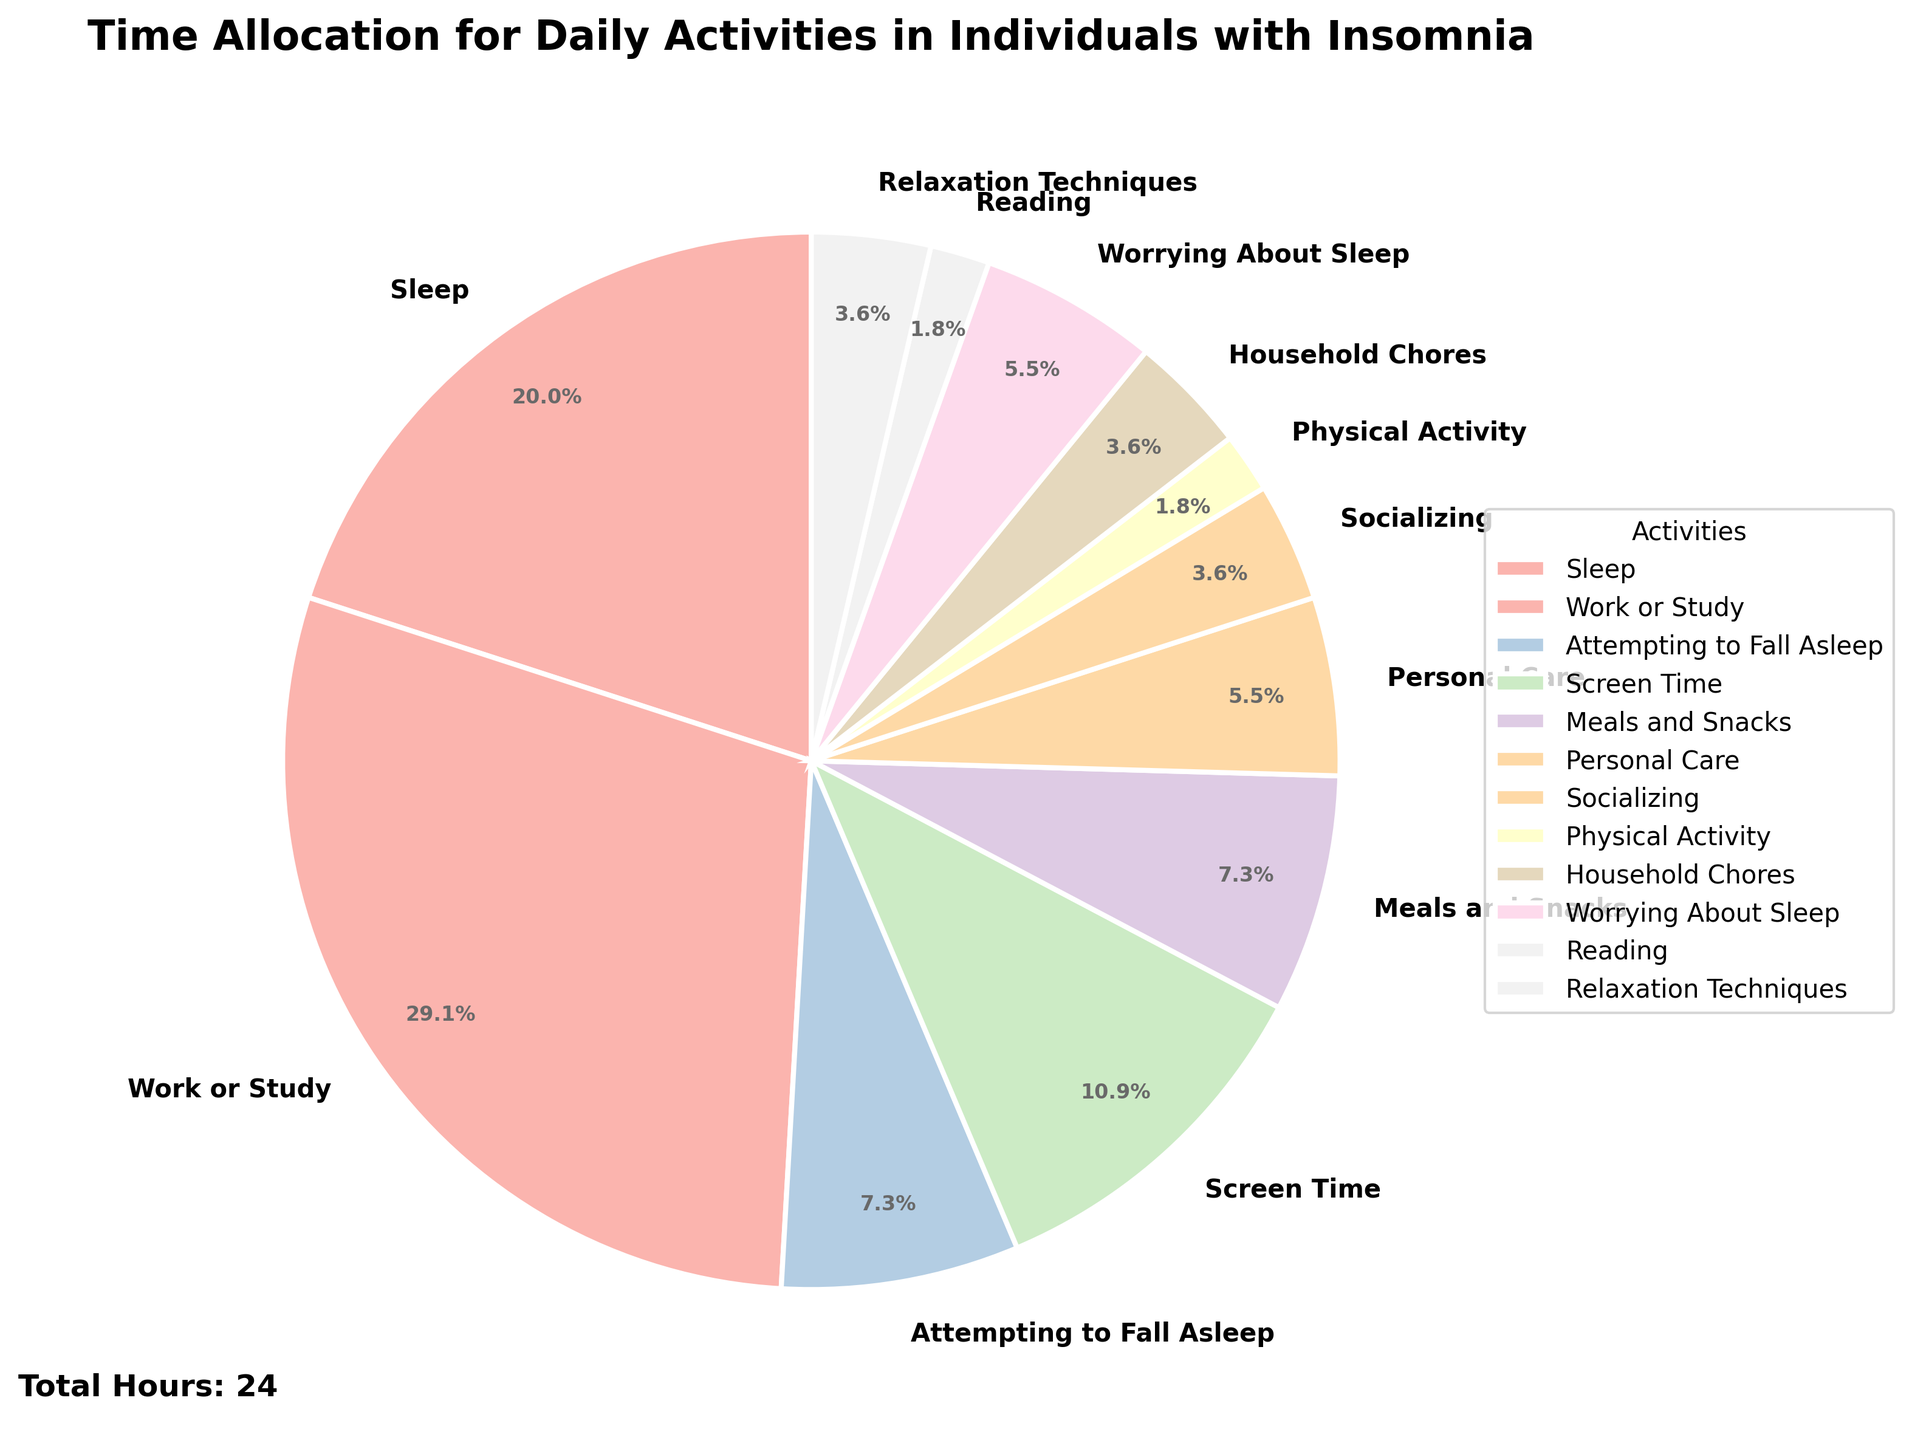What percentage of their day do individuals with insomnia spend on screen time? Total daily hours are 24. Screen time is 3 hours. The percentage is (3/24) * 100.
Answer: 12.5% What activity occupies the largest portion of the day for individuals with insomnia? The activity with the highest hours is Work or Study with 8 hours.
Answer: Work or Study What is the combined percentage of time spent on worrying about sleep and attempting to fall asleep? Combined hours for worrying about sleep and attempting to fall asleep are 1.5 + 2 = 3.5. The percentage is (3.5/24) * 100.
Answer: 14.6% How does the time spent on personal care compare to the time spent on relaxation techniques? Personal care is 1.5 hours, and relaxation techniques are 1 hour. Personal care is more.
Answer: More Are there any activities that take up less than 1 hour? Physical Activity and Reading each take up 0.5 hours.
Answer: Yes (Physical Activity, Reading) What are the top three activities in terms of time allocation? The top three activities are Work or Study (8 hours), Sleep (5.5 hours), and Screen Time (3 hours).
Answer: Work or Study, Sleep, Screen Time What is the difference in hours between work or study and sleep? Work or Study is 8 hours, and Sleep is 5.5 hours. The difference is 8 - 5.5.
Answer: 2.5 hours Which activities are allocated exactly 2 hours each? Attempting to Fall Asleep and Meals and Snacks are each allocated 2 hours.
Answer: Attempting to Fall Asleep, Meals and Snacks If the time spent on sleep were increased by 2 hours, what would be the new total percentage of time spent on sleep? New Sleep time is 5.5 + 2 = 7.5 hours. The percentage is (7.5/24) * 100.
Answer: 31.3% Compare the time spent socializing with the time spent on household chores. Which one is more and by how much? Socializing is 1 hour, and Household Chores is 1 hour. Household Chores are more. The difference is 1 - 1.
Answer: Similar 